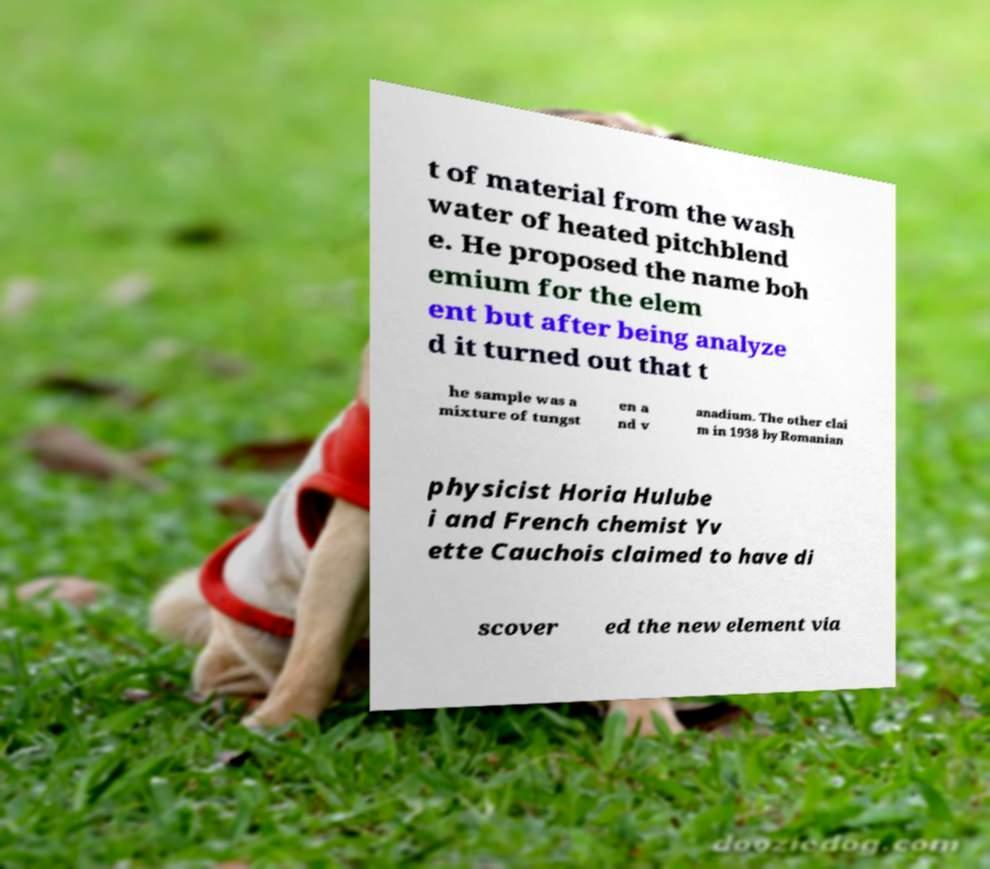Could you assist in decoding the text presented in this image and type it out clearly? t of material from the wash water of heated pitchblend e. He proposed the name boh emium for the elem ent but after being analyze d it turned out that t he sample was a mixture of tungst en a nd v anadium. The other clai m in 1938 by Romanian physicist Horia Hulube i and French chemist Yv ette Cauchois claimed to have di scover ed the new element via 